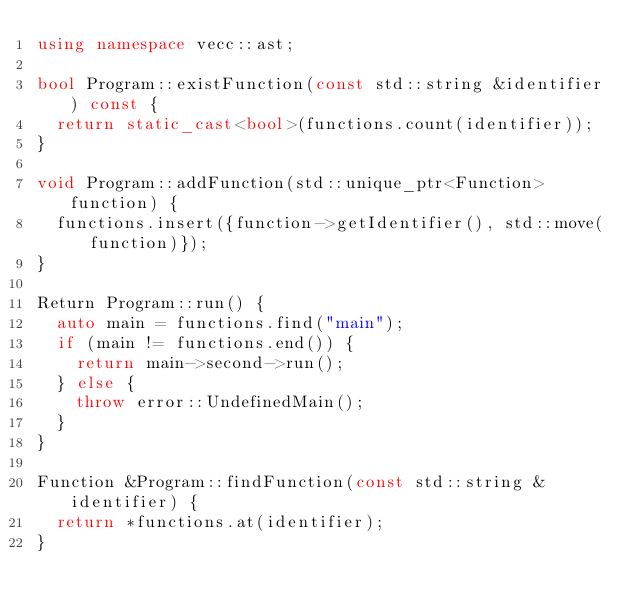Convert code to text. <code><loc_0><loc_0><loc_500><loc_500><_C++_>using namespace vecc::ast;

bool Program::existFunction(const std::string &identifier) const {
  return static_cast<bool>(functions.count(identifier));
}

void Program::addFunction(std::unique_ptr<Function> function) {
  functions.insert({function->getIdentifier(), std::move(function)});
}

Return Program::run() {
  auto main = functions.find("main");
  if (main != functions.end()) {
    return main->second->run();
  } else {
    throw error::UndefinedMain();
  }
}

Function &Program::findFunction(const std::string &identifier) {
  return *functions.at(identifier);
}
</code> 